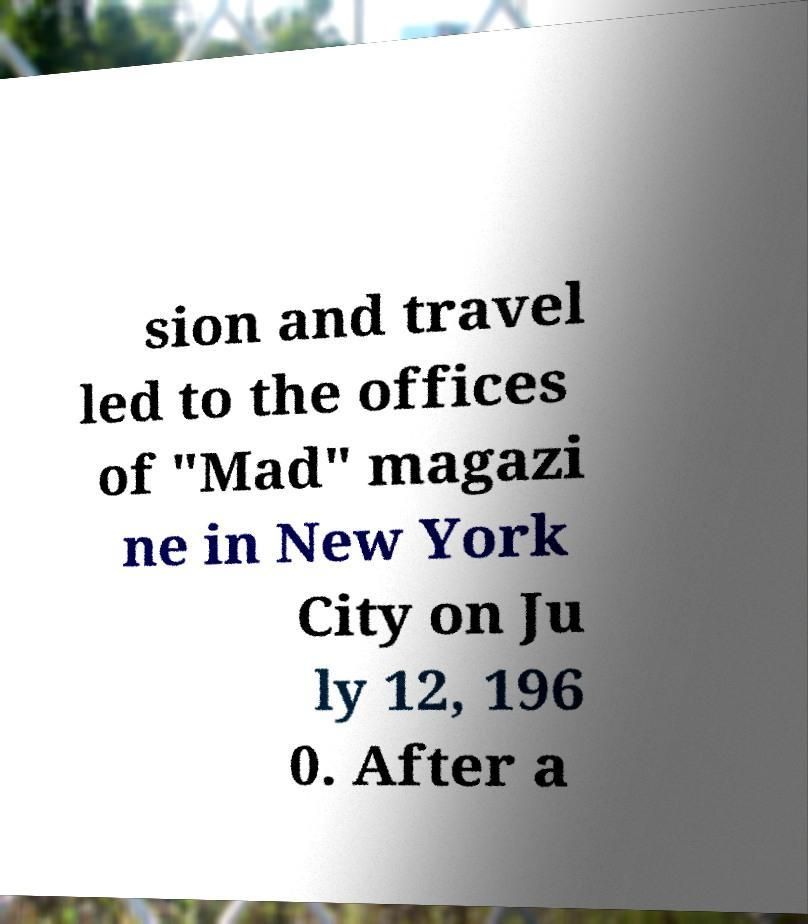Could you extract and type out the text from this image? sion and travel led to the offices of "Mad" magazi ne in New York City on Ju ly 12, 196 0. After a 